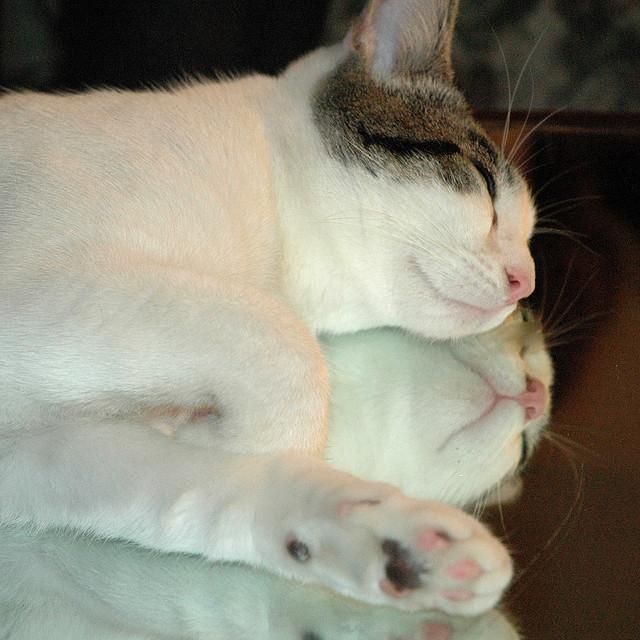How many spots does the cat have?
Give a very brief answer. 0. How many cats are in the picture?
Give a very brief answer. 2. 